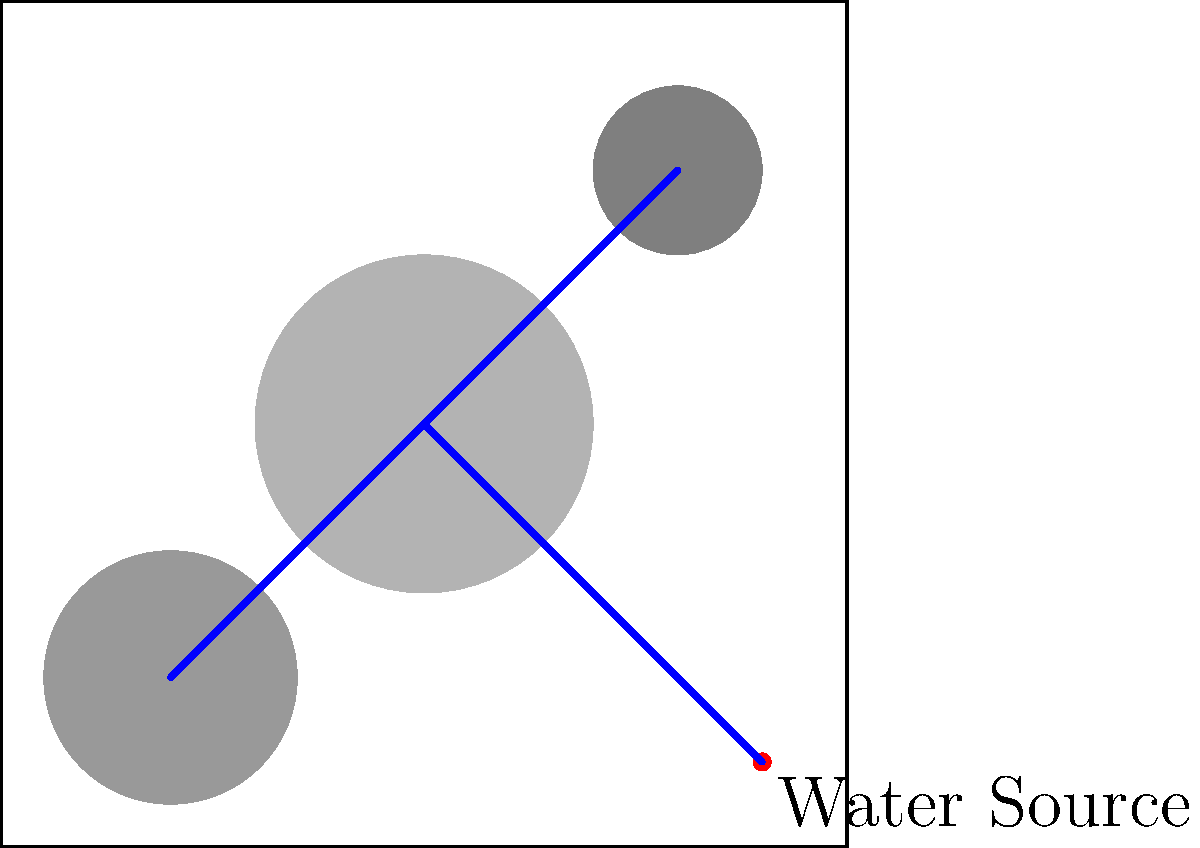Based on the given city map showing population density (darker areas indicate higher density) and the location of the water source, design an efficient water distribution network by identifying the optimal locations for three main water storage tanks. Explain your reasoning and how this design minimizes infrastructure costs while ensuring adequate water supply to all areas. To design an efficient water distribution network, we need to consider several factors:

1. Population density: Higher density areas require more water and should be prioritized.
2. Distance from the water source: Longer distances increase infrastructure costs and potential water loss.
3. Elevation (although not shown in this map): Tanks at higher elevations can use gravity for distribution.

Step-by-step analysis:

1. Identify high-density areas:
   - City center (0,0): Highest density
   - Northeast quadrant (3,3): Medium-high density
   - Southwest quadrant (-3,-3): Medium density

2. Consider distance from the water source:
   - The source is located at (4,-4) in the southeast corner.

3. Optimal tank locations:

   a. Tank 1: City center (0,0)
      - Serves the highest density area
      - Central location allows for efficient distribution to other areas
      - Relatively close to the water source

   b. Tank 2: Northeast quadrant (3,3)
      - Serves the medium-high density area
      - Furthest from the water source, so a tank here reduces the need for long-distance, high-pressure pipelines

   c. Tank 3: Midway between the water source and southwest quadrant (0.5,-3.5)
      - Serves the medium density southwest area
      - Closer to the water source, reducing infrastructure costs
      - Can also support distribution to the city center if needed

4. Main pipeline layout:
   - From source to Tank 1 (city center)
   - From Tank 1 to Tank 2 (northeast)
   - From Tank 1 to Tank 3 (southwest)

This design minimizes infrastructure costs by:
- Placing tanks close to high-demand areas, reducing the need for extensive pipeline networks
- Using the central tank as a hub for distribution, minimizing total pipeline length
- Balancing the distance from the water source to each tank

It ensures adequate water supply by:
- Prioritizing high-density areas with dedicated tanks
- Creating a network that can distribute water efficiently to all areas of the city
- Allowing for redundancy in supply routes (e.g., southwest area can be supplied from Tank 1 or Tank 3)
Answer: Optimal tank locations: (0,0), (3,3), (0.5,-3.5) 